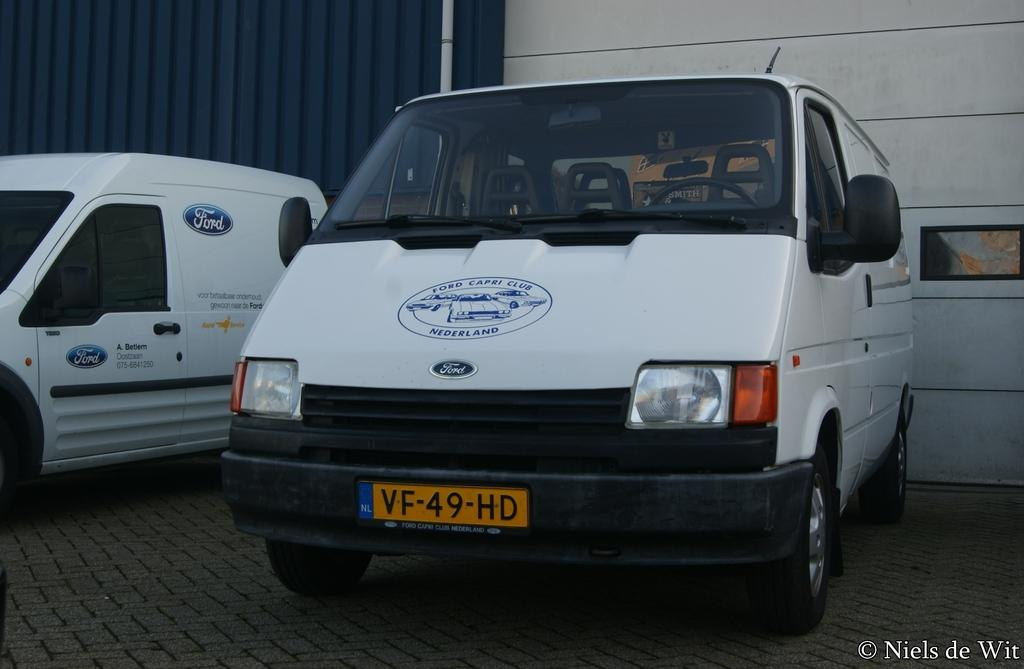Provide a one-sentence caption for the provided image. Commercial vans for a Nederland Ford dealership sit side by side in front of a blue building. 